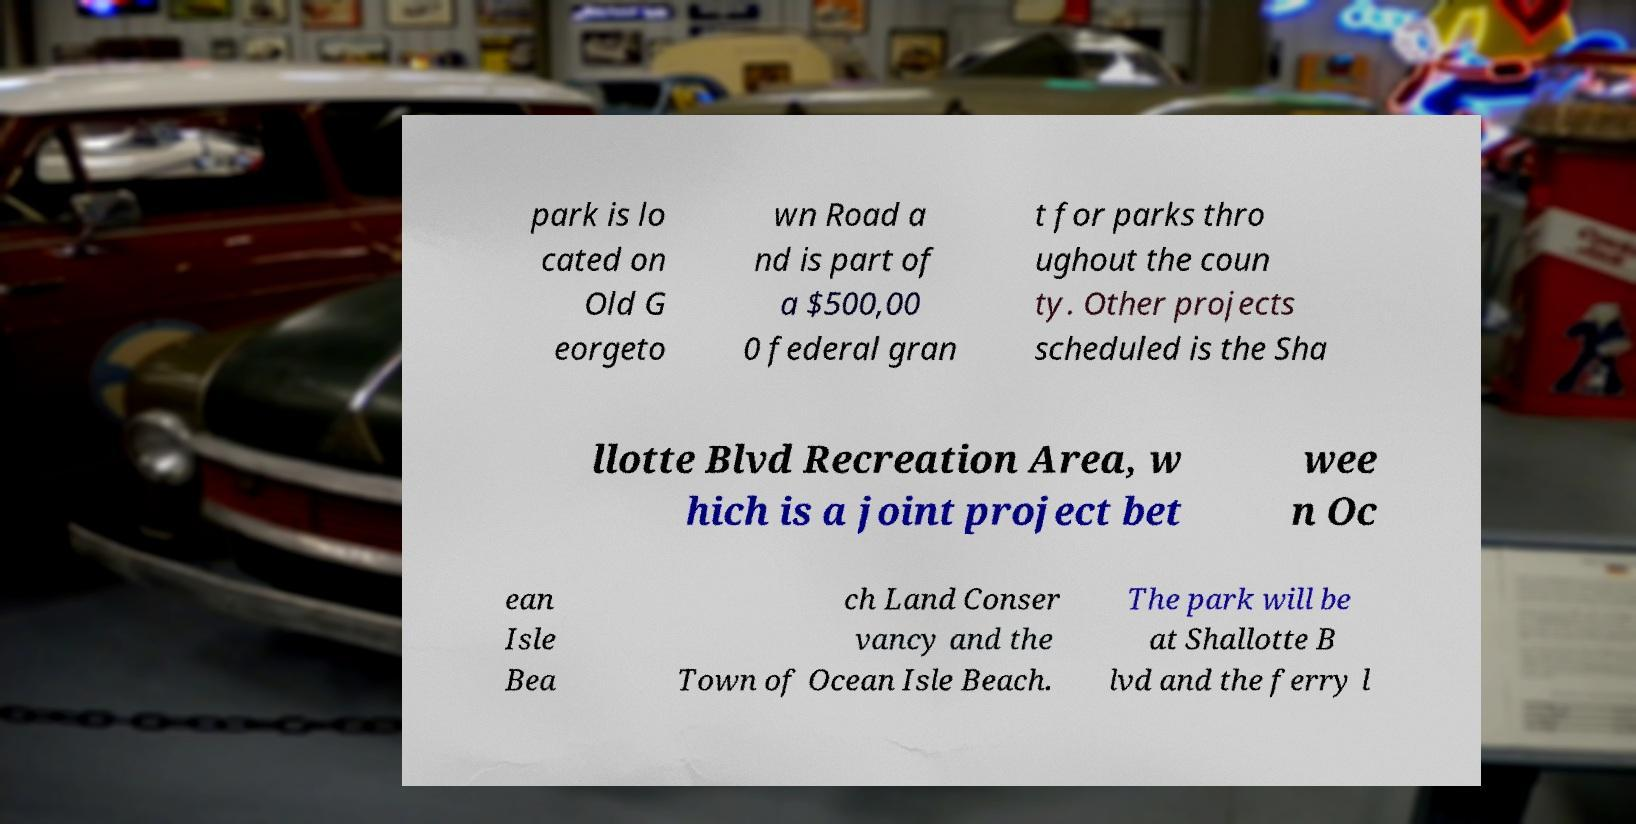What messages or text are displayed in this image? I need them in a readable, typed format. park is lo cated on Old G eorgeto wn Road a nd is part of a $500,00 0 federal gran t for parks thro ughout the coun ty. Other projects scheduled is the Sha llotte Blvd Recreation Area, w hich is a joint project bet wee n Oc ean Isle Bea ch Land Conser vancy and the Town of Ocean Isle Beach. The park will be at Shallotte B lvd and the ferry l 